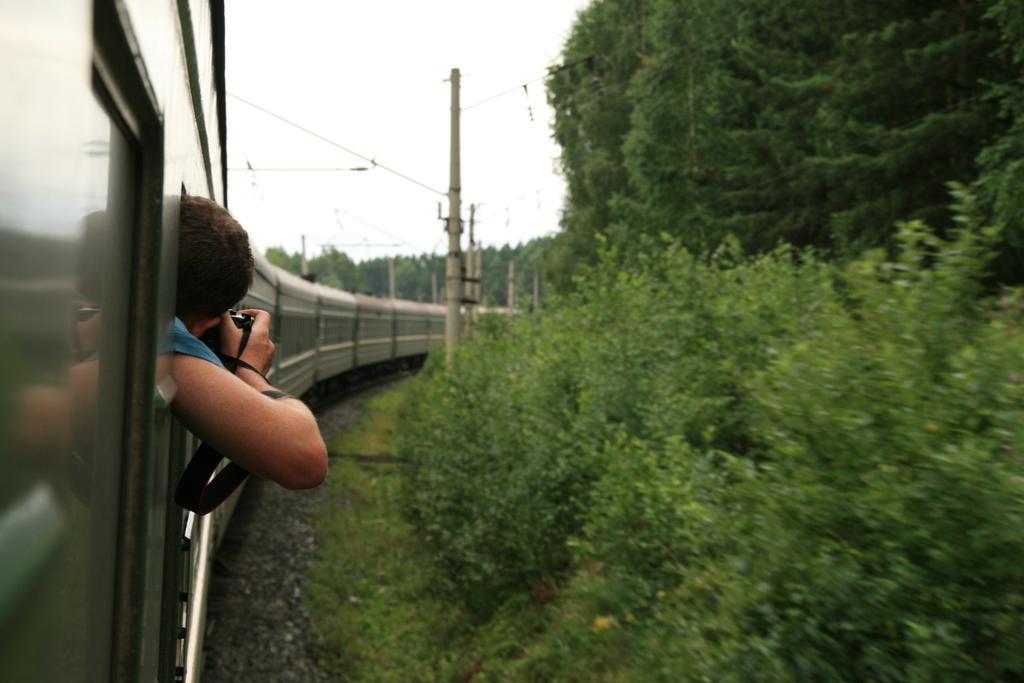In one or two sentences, can you explain what this image depicts? On the left side, there is a person keeping his head outside of a train, holding a camera and capturing. This train is on a railway track. On the right side, there are trees, plants and grass on the ground. In the background, there are electric poles, trees and there are clouds in the sky. 